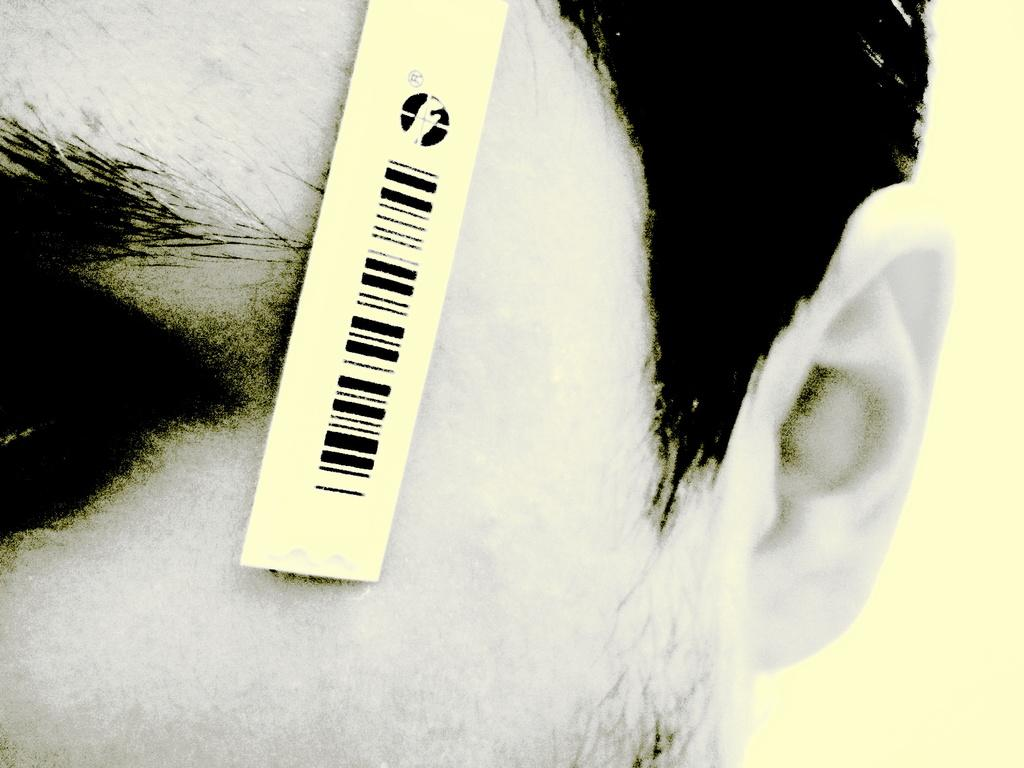What is the main subject of the image? The main subject of the image is a close-up face of a person. Does the face in the image appear to be altered or edited in any way? Yes, the face appears to be edited in the image. What additional detail can be seen in the image? There is a tag with a bar code visible in the image. How many trees can be seen in the image? There are no trees visible in the image; it features a close-up face of a person. What type of statement is being made by the person in the image? There is no statement being made by the person in the image, as it is a close-up of their face and does not show any context or expression. 